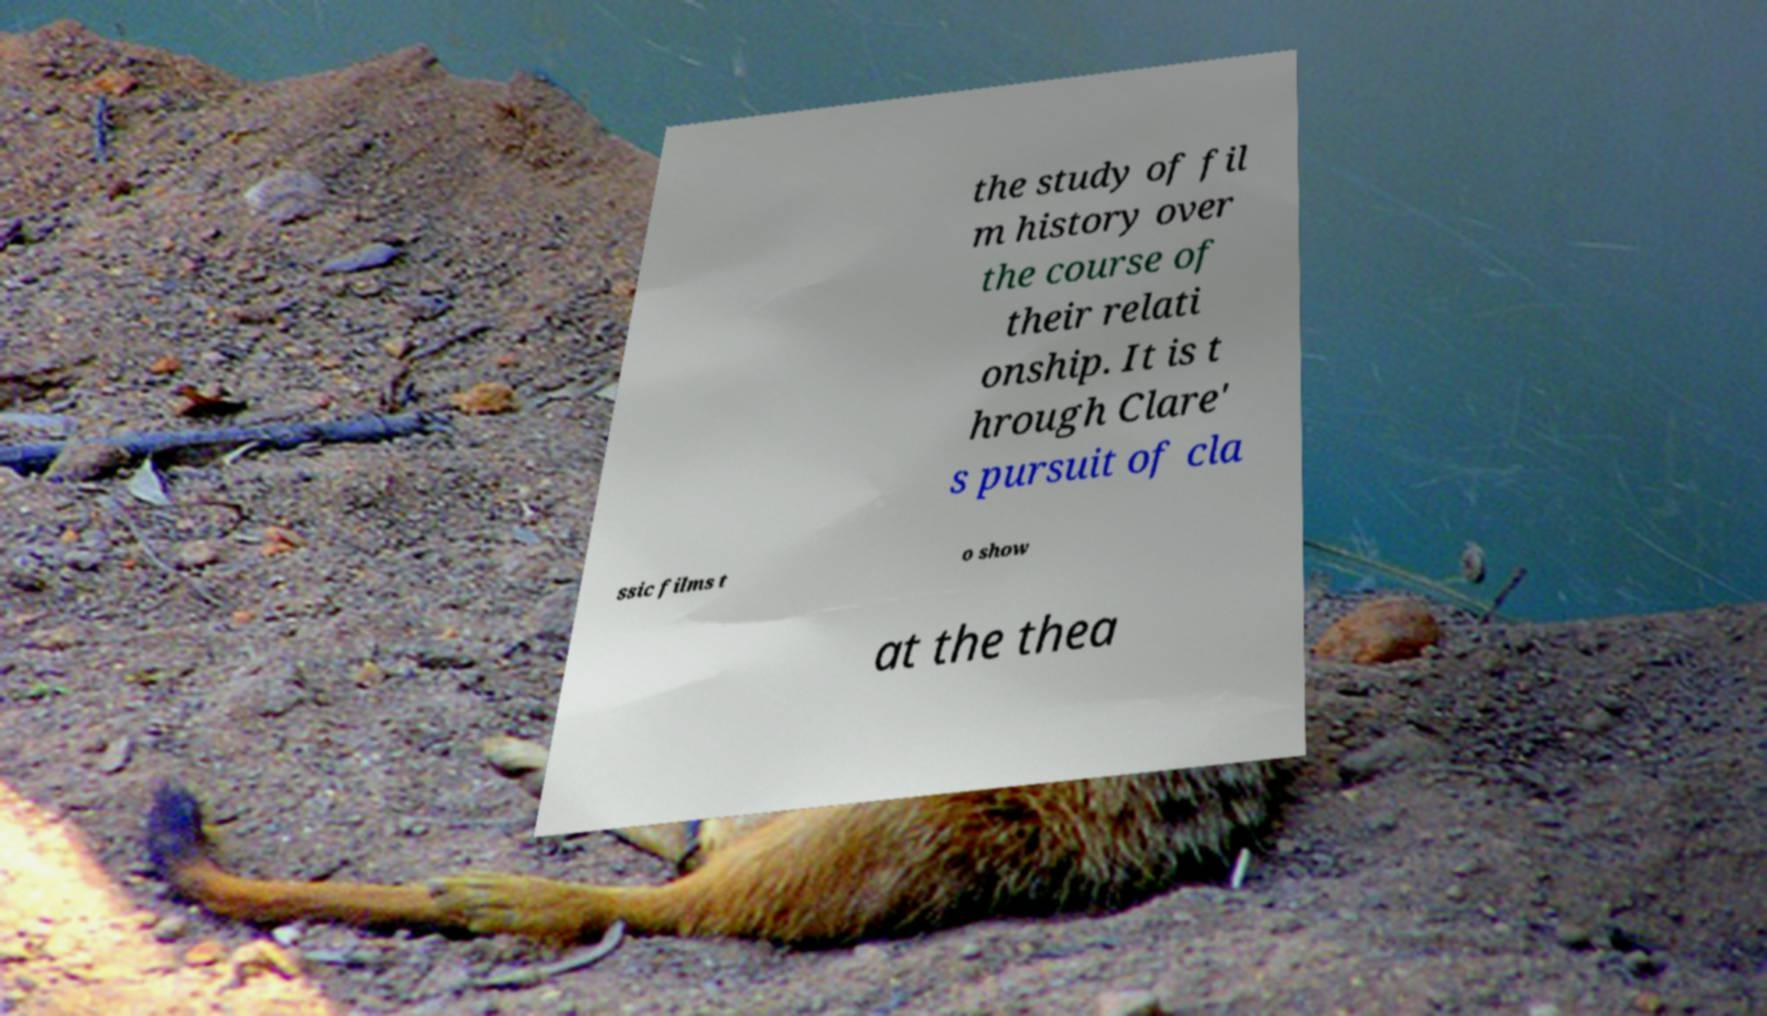Could you assist in decoding the text presented in this image and type it out clearly? the study of fil m history over the course of their relati onship. It is t hrough Clare' s pursuit of cla ssic films t o show at the thea 